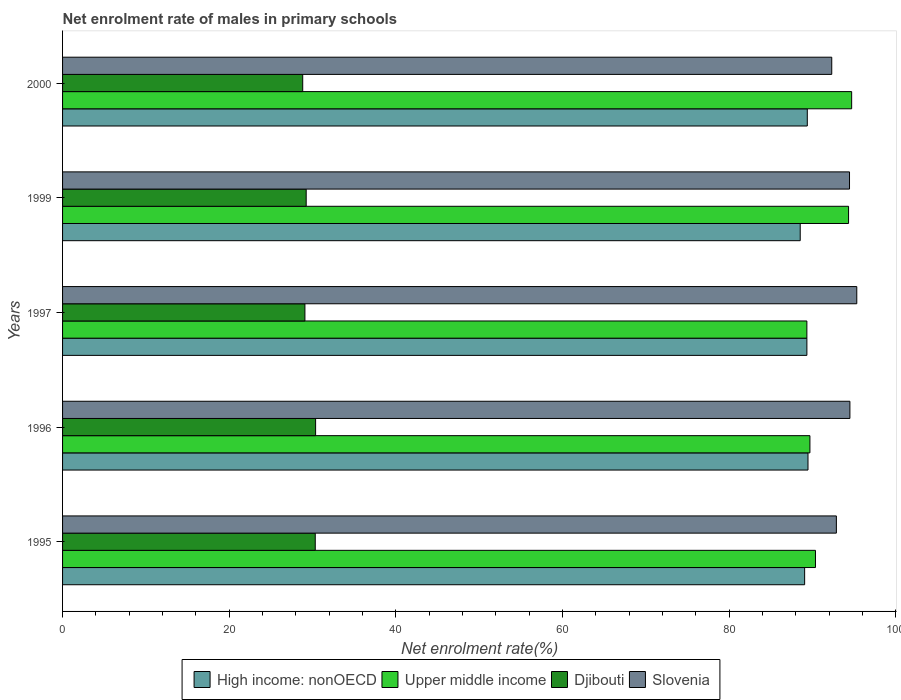How many different coloured bars are there?
Provide a short and direct response. 4. Are the number of bars per tick equal to the number of legend labels?
Your response must be concise. Yes. Are the number of bars on each tick of the Y-axis equal?
Keep it short and to the point. Yes. How many bars are there on the 3rd tick from the top?
Offer a very short reply. 4. How many bars are there on the 5th tick from the bottom?
Your answer should be very brief. 4. What is the label of the 4th group of bars from the top?
Offer a very short reply. 1996. What is the net enrolment rate of males in primary schools in Djibouti in 1997?
Provide a succinct answer. 29.09. Across all years, what is the maximum net enrolment rate of males in primary schools in Djibouti?
Your answer should be very brief. 30.37. Across all years, what is the minimum net enrolment rate of males in primary schools in Slovenia?
Offer a very short reply. 92.31. In which year was the net enrolment rate of males in primary schools in Upper middle income maximum?
Provide a succinct answer. 2000. In which year was the net enrolment rate of males in primary schools in Djibouti minimum?
Make the answer very short. 2000. What is the total net enrolment rate of males in primary schools in Djibouti in the graph?
Keep it short and to the point. 147.84. What is the difference between the net enrolment rate of males in primary schools in Djibouti in 1995 and that in 1996?
Keep it short and to the point. -0.04. What is the difference between the net enrolment rate of males in primary schools in Slovenia in 1997 and the net enrolment rate of males in primary schools in High income: nonOECD in 1999?
Keep it short and to the point. 6.79. What is the average net enrolment rate of males in primary schools in Djibouti per year?
Provide a succinct answer. 29.57. In the year 1996, what is the difference between the net enrolment rate of males in primary schools in Upper middle income and net enrolment rate of males in primary schools in High income: nonOECD?
Give a very brief answer. 0.23. In how many years, is the net enrolment rate of males in primary schools in Djibouti greater than 84 %?
Provide a succinct answer. 0. What is the ratio of the net enrolment rate of males in primary schools in Slovenia in 1996 to that in 2000?
Ensure brevity in your answer.  1.02. What is the difference between the highest and the second highest net enrolment rate of males in primary schools in Djibouti?
Provide a short and direct response. 0.04. What is the difference between the highest and the lowest net enrolment rate of males in primary schools in Slovenia?
Your answer should be compact. 3. In how many years, is the net enrolment rate of males in primary schools in Djibouti greater than the average net enrolment rate of males in primary schools in Djibouti taken over all years?
Make the answer very short. 2. Is it the case that in every year, the sum of the net enrolment rate of males in primary schools in Djibouti and net enrolment rate of males in primary schools in High income: nonOECD is greater than the sum of net enrolment rate of males in primary schools in Upper middle income and net enrolment rate of males in primary schools in Slovenia?
Your answer should be very brief. No. What does the 1st bar from the top in 1995 represents?
Provide a short and direct response. Slovenia. What does the 3rd bar from the bottom in 1996 represents?
Your answer should be compact. Djibouti. How many bars are there?
Keep it short and to the point. 20. What is the difference between two consecutive major ticks on the X-axis?
Your answer should be compact. 20. Does the graph contain any zero values?
Your answer should be compact. No. Does the graph contain grids?
Make the answer very short. No. How many legend labels are there?
Offer a very short reply. 4. What is the title of the graph?
Ensure brevity in your answer.  Net enrolment rate of males in primary schools. What is the label or title of the X-axis?
Your answer should be compact. Net enrolment rate(%). What is the label or title of the Y-axis?
Provide a succinct answer. Years. What is the Net enrolment rate(%) of High income: nonOECD in 1995?
Give a very brief answer. 89.06. What is the Net enrolment rate(%) in Upper middle income in 1995?
Your response must be concise. 90.36. What is the Net enrolment rate(%) in Djibouti in 1995?
Offer a terse response. 30.33. What is the Net enrolment rate(%) in Slovenia in 1995?
Give a very brief answer. 92.87. What is the Net enrolment rate(%) of High income: nonOECD in 1996?
Offer a terse response. 89.46. What is the Net enrolment rate(%) in Upper middle income in 1996?
Provide a short and direct response. 89.69. What is the Net enrolment rate(%) of Djibouti in 1996?
Offer a terse response. 30.37. What is the Net enrolment rate(%) in Slovenia in 1996?
Give a very brief answer. 94.49. What is the Net enrolment rate(%) in High income: nonOECD in 1997?
Provide a succinct answer. 89.33. What is the Net enrolment rate(%) in Upper middle income in 1997?
Offer a very short reply. 89.33. What is the Net enrolment rate(%) in Djibouti in 1997?
Offer a terse response. 29.09. What is the Net enrolment rate(%) of Slovenia in 1997?
Provide a short and direct response. 95.32. What is the Net enrolment rate(%) of High income: nonOECD in 1999?
Give a very brief answer. 88.53. What is the Net enrolment rate(%) of Upper middle income in 1999?
Give a very brief answer. 94.33. What is the Net enrolment rate(%) in Djibouti in 1999?
Provide a succinct answer. 29.24. What is the Net enrolment rate(%) of Slovenia in 1999?
Keep it short and to the point. 94.45. What is the Net enrolment rate(%) in High income: nonOECD in 2000?
Ensure brevity in your answer.  89.38. What is the Net enrolment rate(%) in Upper middle income in 2000?
Keep it short and to the point. 94.7. What is the Net enrolment rate(%) of Djibouti in 2000?
Offer a terse response. 28.82. What is the Net enrolment rate(%) of Slovenia in 2000?
Your response must be concise. 92.31. Across all years, what is the maximum Net enrolment rate(%) of High income: nonOECD?
Keep it short and to the point. 89.46. Across all years, what is the maximum Net enrolment rate(%) in Upper middle income?
Offer a terse response. 94.7. Across all years, what is the maximum Net enrolment rate(%) of Djibouti?
Ensure brevity in your answer.  30.37. Across all years, what is the maximum Net enrolment rate(%) of Slovenia?
Give a very brief answer. 95.32. Across all years, what is the minimum Net enrolment rate(%) of High income: nonOECD?
Keep it short and to the point. 88.53. Across all years, what is the minimum Net enrolment rate(%) of Upper middle income?
Your answer should be very brief. 89.33. Across all years, what is the minimum Net enrolment rate(%) in Djibouti?
Provide a succinct answer. 28.82. Across all years, what is the minimum Net enrolment rate(%) in Slovenia?
Your answer should be compact. 92.31. What is the total Net enrolment rate(%) of High income: nonOECD in the graph?
Keep it short and to the point. 445.76. What is the total Net enrolment rate(%) in Upper middle income in the graph?
Your response must be concise. 458.41. What is the total Net enrolment rate(%) in Djibouti in the graph?
Make the answer very short. 147.84. What is the total Net enrolment rate(%) in Slovenia in the graph?
Give a very brief answer. 469.44. What is the difference between the Net enrolment rate(%) in High income: nonOECD in 1995 and that in 1996?
Your answer should be very brief. -0.4. What is the difference between the Net enrolment rate(%) of Upper middle income in 1995 and that in 1996?
Provide a short and direct response. 0.67. What is the difference between the Net enrolment rate(%) in Djibouti in 1995 and that in 1996?
Your response must be concise. -0.04. What is the difference between the Net enrolment rate(%) of Slovenia in 1995 and that in 1996?
Make the answer very short. -1.63. What is the difference between the Net enrolment rate(%) of High income: nonOECD in 1995 and that in 1997?
Offer a very short reply. -0.27. What is the difference between the Net enrolment rate(%) of Upper middle income in 1995 and that in 1997?
Your answer should be very brief. 1.03. What is the difference between the Net enrolment rate(%) in Djibouti in 1995 and that in 1997?
Offer a terse response. 1.24. What is the difference between the Net enrolment rate(%) in Slovenia in 1995 and that in 1997?
Offer a very short reply. -2.45. What is the difference between the Net enrolment rate(%) in High income: nonOECD in 1995 and that in 1999?
Make the answer very short. 0.53. What is the difference between the Net enrolment rate(%) in Upper middle income in 1995 and that in 1999?
Ensure brevity in your answer.  -3.97. What is the difference between the Net enrolment rate(%) in Djibouti in 1995 and that in 1999?
Make the answer very short. 1.09. What is the difference between the Net enrolment rate(%) in Slovenia in 1995 and that in 1999?
Make the answer very short. -1.58. What is the difference between the Net enrolment rate(%) of High income: nonOECD in 1995 and that in 2000?
Keep it short and to the point. -0.32. What is the difference between the Net enrolment rate(%) of Upper middle income in 1995 and that in 2000?
Ensure brevity in your answer.  -4.34. What is the difference between the Net enrolment rate(%) in Djibouti in 1995 and that in 2000?
Provide a succinct answer. 1.5. What is the difference between the Net enrolment rate(%) of Slovenia in 1995 and that in 2000?
Offer a very short reply. 0.55. What is the difference between the Net enrolment rate(%) of High income: nonOECD in 1996 and that in 1997?
Give a very brief answer. 0.13. What is the difference between the Net enrolment rate(%) of Upper middle income in 1996 and that in 1997?
Keep it short and to the point. 0.37. What is the difference between the Net enrolment rate(%) in Djibouti in 1996 and that in 1997?
Provide a succinct answer. 1.28. What is the difference between the Net enrolment rate(%) in Slovenia in 1996 and that in 1997?
Your answer should be compact. -0.82. What is the difference between the Net enrolment rate(%) in High income: nonOECD in 1996 and that in 1999?
Offer a terse response. 0.93. What is the difference between the Net enrolment rate(%) of Upper middle income in 1996 and that in 1999?
Your answer should be very brief. -4.64. What is the difference between the Net enrolment rate(%) of Djibouti in 1996 and that in 1999?
Give a very brief answer. 1.13. What is the difference between the Net enrolment rate(%) of Slovenia in 1996 and that in 1999?
Ensure brevity in your answer.  0.05. What is the difference between the Net enrolment rate(%) in High income: nonOECD in 1996 and that in 2000?
Provide a short and direct response. 0.08. What is the difference between the Net enrolment rate(%) in Upper middle income in 1996 and that in 2000?
Keep it short and to the point. -5.01. What is the difference between the Net enrolment rate(%) in Djibouti in 1996 and that in 2000?
Offer a very short reply. 1.55. What is the difference between the Net enrolment rate(%) in Slovenia in 1996 and that in 2000?
Ensure brevity in your answer.  2.18. What is the difference between the Net enrolment rate(%) of High income: nonOECD in 1997 and that in 1999?
Ensure brevity in your answer.  0.8. What is the difference between the Net enrolment rate(%) of Upper middle income in 1997 and that in 1999?
Give a very brief answer. -5. What is the difference between the Net enrolment rate(%) of Djibouti in 1997 and that in 1999?
Your response must be concise. -0.15. What is the difference between the Net enrolment rate(%) in Slovenia in 1997 and that in 1999?
Give a very brief answer. 0.87. What is the difference between the Net enrolment rate(%) of High income: nonOECD in 1997 and that in 2000?
Make the answer very short. -0.05. What is the difference between the Net enrolment rate(%) of Upper middle income in 1997 and that in 2000?
Offer a terse response. -5.37. What is the difference between the Net enrolment rate(%) in Djibouti in 1997 and that in 2000?
Keep it short and to the point. 0.26. What is the difference between the Net enrolment rate(%) of Slovenia in 1997 and that in 2000?
Offer a terse response. 3. What is the difference between the Net enrolment rate(%) in High income: nonOECD in 1999 and that in 2000?
Keep it short and to the point. -0.85. What is the difference between the Net enrolment rate(%) in Upper middle income in 1999 and that in 2000?
Provide a succinct answer. -0.37. What is the difference between the Net enrolment rate(%) of Djibouti in 1999 and that in 2000?
Provide a short and direct response. 0.42. What is the difference between the Net enrolment rate(%) of Slovenia in 1999 and that in 2000?
Ensure brevity in your answer.  2.13. What is the difference between the Net enrolment rate(%) of High income: nonOECD in 1995 and the Net enrolment rate(%) of Upper middle income in 1996?
Give a very brief answer. -0.63. What is the difference between the Net enrolment rate(%) of High income: nonOECD in 1995 and the Net enrolment rate(%) of Djibouti in 1996?
Keep it short and to the point. 58.69. What is the difference between the Net enrolment rate(%) in High income: nonOECD in 1995 and the Net enrolment rate(%) in Slovenia in 1996?
Your answer should be very brief. -5.43. What is the difference between the Net enrolment rate(%) in Upper middle income in 1995 and the Net enrolment rate(%) in Djibouti in 1996?
Give a very brief answer. 59.99. What is the difference between the Net enrolment rate(%) in Upper middle income in 1995 and the Net enrolment rate(%) in Slovenia in 1996?
Keep it short and to the point. -4.13. What is the difference between the Net enrolment rate(%) in Djibouti in 1995 and the Net enrolment rate(%) in Slovenia in 1996?
Your answer should be compact. -64.17. What is the difference between the Net enrolment rate(%) in High income: nonOECD in 1995 and the Net enrolment rate(%) in Upper middle income in 1997?
Give a very brief answer. -0.27. What is the difference between the Net enrolment rate(%) in High income: nonOECD in 1995 and the Net enrolment rate(%) in Djibouti in 1997?
Your response must be concise. 59.97. What is the difference between the Net enrolment rate(%) of High income: nonOECD in 1995 and the Net enrolment rate(%) of Slovenia in 1997?
Make the answer very short. -6.26. What is the difference between the Net enrolment rate(%) in Upper middle income in 1995 and the Net enrolment rate(%) in Djibouti in 1997?
Your answer should be very brief. 61.27. What is the difference between the Net enrolment rate(%) in Upper middle income in 1995 and the Net enrolment rate(%) in Slovenia in 1997?
Your response must be concise. -4.96. What is the difference between the Net enrolment rate(%) of Djibouti in 1995 and the Net enrolment rate(%) of Slovenia in 1997?
Provide a short and direct response. -64.99. What is the difference between the Net enrolment rate(%) in High income: nonOECD in 1995 and the Net enrolment rate(%) in Upper middle income in 1999?
Ensure brevity in your answer.  -5.27. What is the difference between the Net enrolment rate(%) of High income: nonOECD in 1995 and the Net enrolment rate(%) of Djibouti in 1999?
Provide a short and direct response. 59.82. What is the difference between the Net enrolment rate(%) in High income: nonOECD in 1995 and the Net enrolment rate(%) in Slovenia in 1999?
Ensure brevity in your answer.  -5.39. What is the difference between the Net enrolment rate(%) of Upper middle income in 1995 and the Net enrolment rate(%) of Djibouti in 1999?
Offer a very short reply. 61.12. What is the difference between the Net enrolment rate(%) in Upper middle income in 1995 and the Net enrolment rate(%) in Slovenia in 1999?
Your response must be concise. -4.09. What is the difference between the Net enrolment rate(%) in Djibouti in 1995 and the Net enrolment rate(%) in Slovenia in 1999?
Provide a succinct answer. -64.12. What is the difference between the Net enrolment rate(%) in High income: nonOECD in 1995 and the Net enrolment rate(%) in Upper middle income in 2000?
Your answer should be compact. -5.64. What is the difference between the Net enrolment rate(%) in High income: nonOECD in 1995 and the Net enrolment rate(%) in Djibouti in 2000?
Make the answer very short. 60.24. What is the difference between the Net enrolment rate(%) in High income: nonOECD in 1995 and the Net enrolment rate(%) in Slovenia in 2000?
Your response must be concise. -3.25. What is the difference between the Net enrolment rate(%) in Upper middle income in 1995 and the Net enrolment rate(%) in Djibouti in 2000?
Provide a short and direct response. 61.54. What is the difference between the Net enrolment rate(%) of Upper middle income in 1995 and the Net enrolment rate(%) of Slovenia in 2000?
Your answer should be very brief. -1.95. What is the difference between the Net enrolment rate(%) of Djibouti in 1995 and the Net enrolment rate(%) of Slovenia in 2000?
Give a very brief answer. -61.99. What is the difference between the Net enrolment rate(%) of High income: nonOECD in 1996 and the Net enrolment rate(%) of Upper middle income in 1997?
Make the answer very short. 0.13. What is the difference between the Net enrolment rate(%) in High income: nonOECD in 1996 and the Net enrolment rate(%) in Djibouti in 1997?
Keep it short and to the point. 60.38. What is the difference between the Net enrolment rate(%) in High income: nonOECD in 1996 and the Net enrolment rate(%) in Slovenia in 1997?
Your answer should be very brief. -5.85. What is the difference between the Net enrolment rate(%) of Upper middle income in 1996 and the Net enrolment rate(%) of Djibouti in 1997?
Offer a terse response. 60.61. What is the difference between the Net enrolment rate(%) of Upper middle income in 1996 and the Net enrolment rate(%) of Slovenia in 1997?
Keep it short and to the point. -5.62. What is the difference between the Net enrolment rate(%) in Djibouti in 1996 and the Net enrolment rate(%) in Slovenia in 1997?
Offer a very short reply. -64.95. What is the difference between the Net enrolment rate(%) of High income: nonOECD in 1996 and the Net enrolment rate(%) of Upper middle income in 1999?
Provide a short and direct response. -4.87. What is the difference between the Net enrolment rate(%) of High income: nonOECD in 1996 and the Net enrolment rate(%) of Djibouti in 1999?
Your answer should be compact. 60.22. What is the difference between the Net enrolment rate(%) of High income: nonOECD in 1996 and the Net enrolment rate(%) of Slovenia in 1999?
Provide a short and direct response. -4.98. What is the difference between the Net enrolment rate(%) in Upper middle income in 1996 and the Net enrolment rate(%) in Djibouti in 1999?
Your answer should be very brief. 60.46. What is the difference between the Net enrolment rate(%) of Upper middle income in 1996 and the Net enrolment rate(%) of Slovenia in 1999?
Offer a very short reply. -4.75. What is the difference between the Net enrolment rate(%) of Djibouti in 1996 and the Net enrolment rate(%) of Slovenia in 1999?
Your response must be concise. -64.08. What is the difference between the Net enrolment rate(%) in High income: nonOECD in 1996 and the Net enrolment rate(%) in Upper middle income in 2000?
Give a very brief answer. -5.24. What is the difference between the Net enrolment rate(%) in High income: nonOECD in 1996 and the Net enrolment rate(%) in Djibouti in 2000?
Make the answer very short. 60.64. What is the difference between the Net enrolment rate(%) in High income: nonOECD in 1996 and the Net enrolment rate(%) in Slovenia in 2000?
Your answer should be compact. -2.85. What is the difference between the Net enrolment rate(%) in Upper middle income in 1996 and the Net enrolment rate(%) in Djibouti in 2000?
Give a very brief answer. 60.87. What is the difference between the Net enrolment rate(%) in Upper middle income in 1996 and the Net enrolment rate(%) in Slovenia in 2000?
Keep it short and to the point. -2.62. What is the difference between the Net enrolment rate(%) of Djibouti in 1996 and the Net enrolment rate(%) of Slovenia in 2000?
Offer a terse response. -61.94. What is the difference between the Net enrolment rate(%) in High income: nonOECD in 1997 and the Net enrolment rate(%) in Upper middle income in 1999?
Provide a short and direct response. -5. What is the difference between the Net enrolment rate(%) of High income: nonOECD in 1997 and the Net enrolment rate(%) of Djibouti in 1999?
Provide a short and direct response. 60.09. What is the difference between the Net enrolment rate(%) in High income: nonOECD in 1997 and the Net enrolment rate(%) in Slovenia in 1999?
Keep it short and to the point. -5.12. What is the difference between the Net enrolment rate(%) of Upper middle income in 1997 and the Net enrolment rate(%) of Djibouti in 1999?
Your answer should be very brief. 60.09. What is the difference between the Net enrolment rate(%) in Upper middle income in 1997 and the Net enrolment rate(%) in Slovenia in 1999?
Offer a terse response. -5.12. What is the difference between the Net enrolment rate(%) of Djibouti in 1997 and the Net enrolment rate(%) of Slovenia in 1999?
Offer a terse response. -65.36. What is the difference between the Net enrolment rate(%) of High income: nonOECD in 1997 and the Net enrolment rate(%) of Upper middle income in 2000?
Keep it short and to the point. -5.37. What is the difference between the Net enrolment rate(%) of High income: nonOECD in 1997 and the Net enrolment rate(%) of Djibouti in 2000?
Offer a very short reply. 60.51. What is the difference between the Net enrolment rate(%) of High income: nonOECD in 1997 and the Net enrolment rate(%) of Slovenia in 2000?
Provide a succinct answer. -2.98. What is the difference between the Net enrolment rate(%) of Upper middle income in 1997 and the Net enrolment rate(%) of Djibouti in 2000?
Provide a short and direct response. 60.51. What is the difference between the Net enrolment rate(%) of Upper middle income in 1997 and the Net enrolment rate(%) of Slovenia in 2000?
Your response must be concise. -2.99. What is the difference between the Net enrolment rate(%) of Djibouti in 1997 and the Net enrolment rate(%) of Slovenia in 2000?
Offer a very short reply. -63.23. What is the difference between the Net enrolment rate(%) in High income: nonOECD in 1999 and the Net enrolment rate(%) in Upper middle income in 2000?
Provide a short and direct response. -6.17. What is the difference between the Net enrolment rate(%) of High income: nonOECD in 1999 and the Net enrolment rate(%) of Djibouti in 2000?
Make the answer very short. 59.71. What is the difference between the Net enrolment rate(%) in High income: nonOECD in 1999 and the Net enrolment rate(%) in Slovenia in 2000?
Your answer should be very brief. -3.79. What is the difference between the Net enrolment rate(%) in Upper middle income in 1999 and the Net enrolment rate(%) in Djibouti in 2000?
Keep it short and to the point. 65.51. What is the difference between the Net enrolment rate(%) of Upper middle income in 1999 and the Net enrolment rate(%) of Slovenia in 2000?
Your answer should be very brief. 2.02. What is the difference between the Net enrolment rate(%) in Djibouti in 1999 and the Net enrolment rate(%) in Slovenia in 2000?
Your answer should be compact. -63.08. What is the average Net enrolment rate(%) of High income: nonOECD per year?
Your response must be concise. 89.15. What is the average Net enrolment rate(%) in Upper middle income per year?
Your answer should be very brief. 91.68. What is the average Net enrolment rate(%) of Djibouti per year?
Ensure brevity in your answer.  29.57. What is the average Net enrolment rate(%) in Slovenia per year?
Your answer should be compact. 93.89. In the year 1995, what is the difference between the Net enrolment rate(%) of High income: nonOECD and Net enrolment rate(%) of Upper middle income?
Provide a succinct answer. -1.3. In the year 1995, what is the difference between the Net enrolment rate(%) of High income: nonOECD and Net enrolment rate(%) of Djibouti?
Your answer should be very brief. 58.73. In the year 1995, what is the difference between the Net enrolment rate(%) of High income: nonOECD and Net enrolment rate(%) of Slovenia?
Keep it short and to the point. -3.81. In the year 1995, what is the difference between the Net enrolment rate(%) in Upper middle income and Net enrolment rate(%) in Djibouti?
Your response must be concise. 60.03. In the year 1995, what is the difference between the Net enrolment rate(%) of Upper middle income and Net enrolment rate(%) of Slovenia?
Your response must be concise. -2.51. In the year 1995, what is the difference between the Net enrolment rate(%) in Djibouti and Net enrolment rate(%) in Slovenia?
Ensure brevity in your answer.  -62.54. In the year 1996, what is the difference between the Net enrolment rate(%) in High income: nonOECD and Net enrolment rate(%) in Upper middle income?
Ensure brevity in your answer.  -0.23. In the year 1996, what is the difference between the Net enrolment rate(%) of High income: nonOECD and Net enrolment rate(%) of Djibouti?
Keep it short and to the point. 59.09. In the year 1996, what is the difference between the Net enrolment rate(%) in High income: nonOECD and Net enrolment rate(%) in Slovenia?
Your answer should be compact. -5.03. In the year 1996, what is the difference between the Net enrolment rate(%) of Upper middle income and Net enrolment rate(%) of Djibouti?
Provide a short and direct response. 59.32. In the year 1996, what is the difference between the Net enrolment rate(%) of Upper middle income and Net enrolment rate(%) of Slovenia?
Offer a very short reply. -4.8. In the year 1996, what is the difference between the Net enrolment rate(%) in Djibouti and Net enrolment rate(%) in Slovenia?
Your response must be concise. -64.12. In the year 1997, what is the difference between the Net enrolment rate(%) in High income: nonOECD and Net enrolment rate(%) in Upper middle income?
Offer a terse response. 0. In the year 1997, what is the difference between the Net enrolment rate(%) of High income: nonOECD and Net enrolment rate(%) of Djibouti?
Keep it short and to the point. 60.24. In the year 1997, what is the difference between the Net enrolment rate(%) in High income: nonOECD and Net enrolment rate(%) in Slovenia?
Keep it short and to the point. -5.99. In the year 1997, what is the difference between the Net enrolment rate(%) of Upper middle income and Net enrolment rate(%) of Djibouti?
Provide a succinct answer. 60.24. In the year 1997, what is the difference between the Net enrolment rate(%) of Upper middle income and Net enrolment rate(%) of Slovenia?
Offer a terse response. -5.99. In the year 1997, what is the difference between the Net enrolment rate(%) in Djibouti and Net enrolment rate(%) in Slovenia?
Ensure brevity in your answer.  -66.23. In the year 1999, what is the difference between the Net enrolment rate(%) in High income: nonOECD and Net enrolment rate(%) in Upper middle income?
Your response must be concise. -5.8. In the year 1999, what is the difference between the Net enrolment rate(%) of High income: nonOECD and Net enrolment rate(%) of Djibouti?
Ensure brevity in your answer.  59.29. In the year 1999, what is the difference between the Net enrolment rate(%) in High income: nonOECD and Net enrolment rate(%) in Slovenia?
Give a very brief answer. -5.92. In the year 1999, what is the difference between the Net enrolment rate(%) of Upper middle income and Net enrolment rate(%) of Djibouti?
Your response must be concise. 65.09. In the year 1999, what is the difference between the Net enrolment rate(%) in Upper middle income and Net enrolment rate(%) in Slovenia?
Offer a very short reply. -0.12. In the year 1999, what is the difference between the Net enrolment rate(%) in Djibouti and Net enrolment rate(%) in Slovenia?
Make the answer very short. -65.21. In the year 2000, what is the difference between the Net enrolment rate(%) in High income: nonOECD and Net enrolment rate(%) in Upper middle income?
Offer a very short reply. -5.32. In the year 2000, what is the difference between the Net enrolment rate(%) of High income: nonOECD and Net enrolment rate(%) of Djibouti?
Your answer should be very brief. 60.56. In the year 2000, what is the difference between the Net enrolment rate(%) in High income: nonOECD and Net enrolment rate(%) in Slovenia?
Your response must be concise. -2.94. In the year 2000, what is the difference between the Net enrolment rate(%) of Upper middle income and Net enrolment rate(%) of Djibouti?
Provide a short and direct response. 65.88. In the year 2000, what is the difference between the Net enrolment rate(%) of Upper middle income and Net enrolment rate(%) of Slovenia?
Keep it short and to the point. 2.39. In the year 2000, what is the difference between the Net enrolment rate(%) in Djibouti and Net enrolment rate(%) in Slovenia?
Keep it short and to the point. -63.49. What is the ratio of the Net enrolment rate(%) of Upper middle income in 1995 to that in 1996?
Keep it short and to the point. 1.01. What is the ratio of the Net enrolment rate(%) in Slovenia in 1995 to that in 1996?
Your answer should be compact. 0.98. What is the ratio of the Net enrolment rate(%) in Upper middle income in 1995 to that in 1997?
Give a very brief answer. 1.01. What is the ratio of the Net enrolment rate(%) of Djibouti in 1995 to that in 1997?
Provide a succinct answer. 1.04. What is the ratio of the Net enrolment rate(%) of Slovenia in 1995 to that in 1997?
Your response must be concise. 0.97. What is the ratio of the Net enrolment rate(%) in High income: nonOECD in 1995 to that in 1999?
Your answer should be compact. 1.01. What is the ratio of the Net enrolment rate(%) in Upper middle income in 1995 to that in 1999?
Offer a terse response. 0.96. What is the ratio of the Net enrolment rate(%) of Djibouti in 1995 to that in 1999?
Offer a very short reply. 1.04. What is the ratio of the Net enrolment rate(%) of Slovenia in 1995 to that in 1999?
Provide a short and direct response. 0.98. What is the ratio of the Net enrolment rate(%) of High income: nonOECD in 1995 to that in 2000?
Provide a succinct answer. 1. What is the ratio of the Net enrolment rate(%) in Upper middle income in 1995 to that in 2000?
Ensure brevity in your answer.  0.95. What is the ratio of the Net enrolment rate(%) in Djibouti in 1995 to that in 2000?
Keep it short and to the point. 1.05. What is the ratio of the Net enrolment rate(%) in Slovenia in 1995 to that in 2000?
Provide a short and direct response. 1.01. What is the ratio of the Net enrolment rate(%) in Upper middle income in 1996 to that in 1997?
Your answer should be compact. 1. What is the ratio of the Net enrolment rate(%) in Djibouti in 1996 to that in 1997?
Give a very brief answer. 1.04. What is the ratio of the Net enrolment rate(%) in High income: nonOECD in 1996 to that in 1999?
Your answer should be very brief. 1.01. What is the ratio of the Net enrolment rate(%) of Upper middle income in 1996 to that in 1999?
Your answer should be very brief. 0.95. What is the ratio of the Net enrolment rate(%) of Djibouti in 1996 to that in 1999?
Provide a succinct answer. 1.04. What is the ratio of the Net enrolment rate(%) in Slovenia in 1996 to that in 1999?
Provide a succinct answer. 1. What is the ratio of the Net enrolment rate(%) of Upper middle income in 1996 to that in 2000?
Make the answer very short. 0.95. What is the ratio of the Net enrolment rate(%) in Djibouti in 1996 to that in 2000?
Provide a succinct answer. 1.05. What is the ratio of the Net enrolment rate(%) in Slovenia in 1996 to that in 2000?
Ensure brevity in your answer.  1.02. What is the ratio of the Net enrolment rate(%) in Upper middle income in 1997 to that in 1999?
Provide a succinct answer. 0.95. What is the ratio of the Net enrolment rate(%) of Djibouti in 1997 to that in 1999?
Your answer should be very brief. 0.99. What is the ratio of the Net enrolment rate(%) of Slovenia in 1997 to that in 1999?
Offer a terse response. 1.01. What is the ratio of the Net enrolment rate(%) of Upper middle income in 1997 to that in 2000?
Your answer should be very brief. 0.94. What is the ratio of the Net enrolment rate(%) in Djibouti in 1997 to that in 2000?
Offer a terse response. 1.01. What is the ratio of the Net enrolment rate(%) of Slovenia in 1997 to that in 2000?
Provide a short and direct response. 1.03. What is the ratio of the Net enrolment rate(%) of Djibouti in 1999 to that in 2000?
Your response must be concise. 1.01. What is the ratio of the Net enrolment rate(%) of Slovenia in 1999 to that in 2000?
Offer a very short reply. 1.02. What is the difference between the highest and the second highest Net enrolment rate(%) of High income: nonOECD?
Offer a very short reply. 0.08. What is the difference between the highest and the second highest Net enrolment rate(%) of Upper middle income?
Your answer should be compact. 0.37. What is the difference between the highest and the second highest Net enrolment rate(%) in Djibouti?
Your answer should be very brief. 0.04. What is the difference between the highest and the second highest Net enrolment rate(%) in Slovenia?
Keep it short and to the point. 0.82. What is the difference between the highest and the lowest Net enrolment rate(%) in High income: nonOECD?
Keep it short and to the point. 0.93. What is the difference between the highest and the lowest Net enrolment rate(%) of Upper middle income?
Offer a terse response. 5.37. What is the difference between the highest and the lowest Net enrolment rate(%) of Djibouti?
Ensure brevity in your answer.  1.55. What is the difference between the highest and the lowest Net enrolment rate(%) in Slovenia?
Ensure brevity in your answer.  3. 